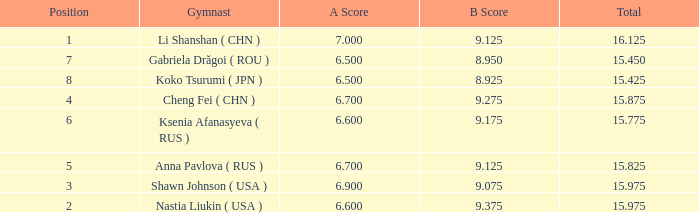What the B Score when the total is 16.125 and the position is less than 7? 9.125. 